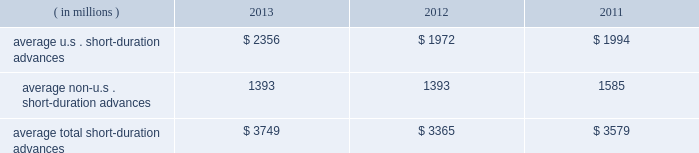Management 2019s discussion and analysis of financial condition and results of operations ( continued ) the table presents average u.s .
And non-u.s .
Short-duration advances for the years ended december 31 : years ended december 31 .
Although average short-duration advances for the year ended december 31 , 2013 increased compared to the year ended december 31 , 2012 , such average advances remained low relative to historical levels , mainly the result of clients continuing to hold higher levels of liquidity .
Average other interest-earning assets increased to $ 11.16 billion for the year ended december 31 , 2013 from $ 7.38 billion for the year ended december 31 , 2012 .
The increased levels were primarily the result of higher levels of cash collateral provided in connection with our participation in principal securities finance transactions .
Aggregate average interest-bearing deposits increased to $ 109.25 billion for the year ended december 31 , 2013 from $ 98.39 billion for the year ended december 31 , 2012 .
This increase was mainly due to higher levels of non-u.s .
Transaction accounts associated with the growth of new and existing business in assets under custody and administration .
Future transaction account levels will be influenced by the underlying asset servicing business , as well as market conditions , including the general levels of u.s .
And non-u.s .
Interest rates .
Average other short-term borrowings declined to $ 3.79 billion for the year ended december 31 , 2013 from $ 4.68 billion for the year ended december 31 , 2012 , as higher levels of client deposits provided additional liquidity .
Average long-term debt increased to $ 8.42 billion for the year ended december 31 , 2013 from $ 7.01 billion for the year ended december 31 , 2012 .
The increase primarily reflected the issuance of $ 1.0 billion of extendible notes by state street bank in december 2012 , the issuance of $ 1.5 billion of senior and subordinated debt in may 2013 , and the issuance of $ 1.0 billion of senior debt in november 2013 .
This increase was partly offset by maturities of $ 1.75 billion of senior debt in the second quarter of 2012 .
Average other interest-bearing liabilities increased to $ 6.46 billion for the year ended december 31 , 2013 from $ 5.90 billion for the year ended december 31 , 2012 , primarily the result of higher levels of cash collateral received from clients in connection with our participation in principal securities finance transactions .
Several factors could affect future levels of our net interest revenue and margin , including the mix of client liabilities ; actions of various central banks ; changes in u.s .
And non-u.s .
Interest rates ; changes in the various yield curves around the world ; revised or proposed regulatory capital or liquidity standards , or interpretations of those standards ; the amount of discount accretion generated by the former conduit securities that remain in our investment securities portfolio ; and the yields earned on securities purchased compared to the yields earned on securities sold or matured .
Based on market conditions and other factors , we continue to reinvest the majority of the proceeds from pay- downs and maturities of investment securities in highly-rated securities , such as u.s .
Treasury and agency securities , federal agency mortgage-backed securities and u.s .
And non-u.s .
Mortgage- and asset-backed securities .
The pace at which we continue to reinvest and the types of investment securities purchased will depend on the impact of market conditions and other factors over time .
We expect these factors and the levels of global interest rates to dictate what effect our reinvestment program will have on future levels of our net interest revenue and net interest margin. .
In 2013 , what percent of short duration advances is from the us? 
Computations: (2356 / 3749)
Answer: 0.62843. 